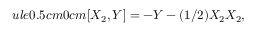<formula> <loc_0><loc_0><loc_500><loc_500>u l e { 0 . 5 c m } { 0 c m } [ X _ { 2 } , Y ] = - Y - ( 1 / 2 ) X _ { 2 } X _ { 2 } ,</formula> 